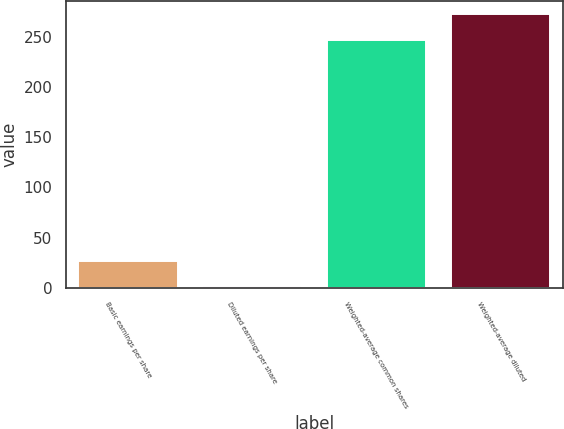<chart> <loc_0><loc_0><loc_500><loc_500><bar_chart><fcel>Basic earnings per share<fcel>Diluted earnings per share<fcel>Weighted-average common shares<fcel>Weighted-average diluted<nl><fcel>26.85<fcel>1.82<fcel>247.2<fcel>272.23<nl></chart> 